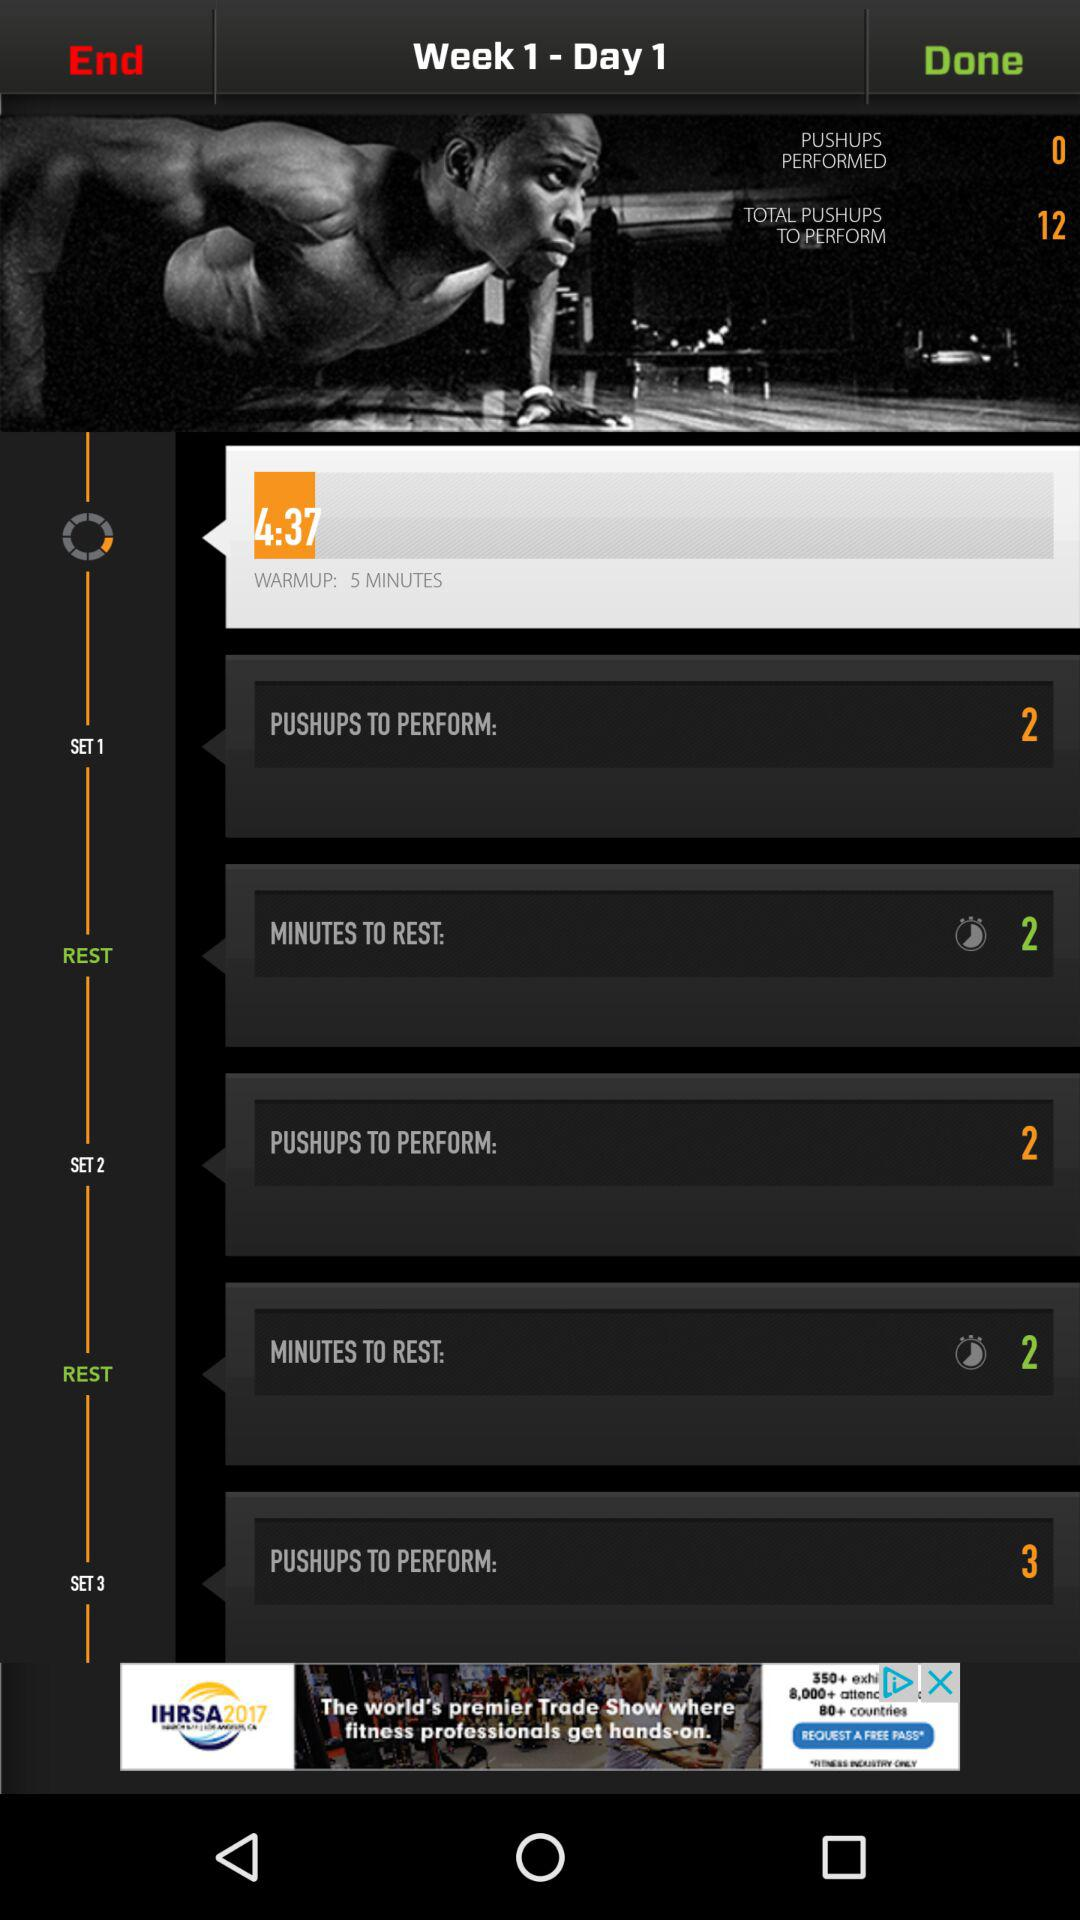What is the warmup time? The warmup time is 5 minutes. 